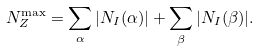<formula> <loc_0><loc_0><loc_500><loc_500>N _ { Z } ^ { \max } = \sum _ { \alpha } | N _ { I } ( \alpha ) | + \sum _ { \beta } | N _ { I } ( \beta ) | .</formula> 